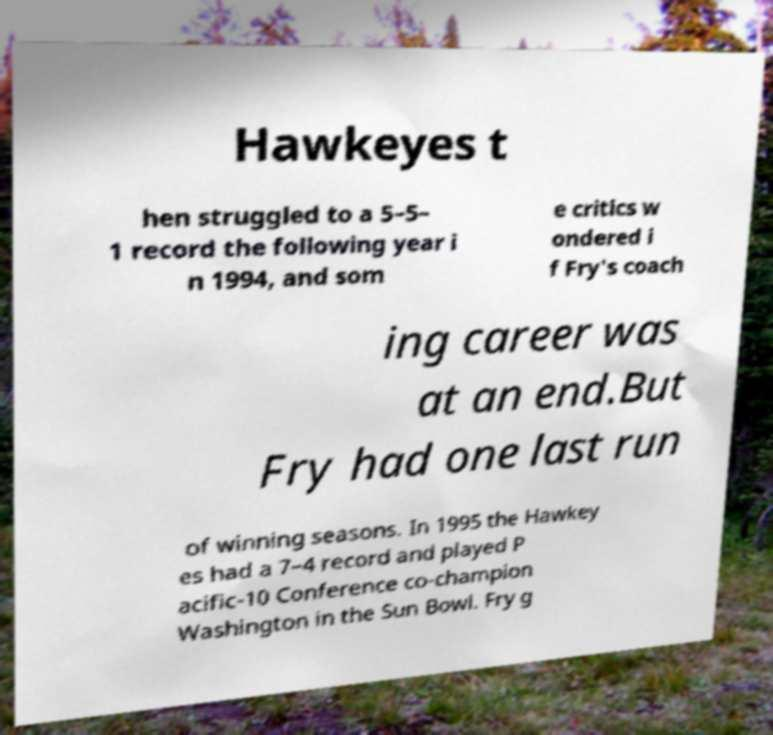Can you read and provide the text displayed in the image?This photo seems to have some interesting text. Can you extract and type it out for me? Hawkeyes t hen struggled to a 5–5– 1 record the following year i n 1994, and som e critics w ondered i f Fry's coach ing career was at an end.But Fry had one last run of winning seasons. In 1995 the Hawkey es had a 7–4 record and played P acific-10 Conference co-champion Washington in the Sun Bowl. Fry g 